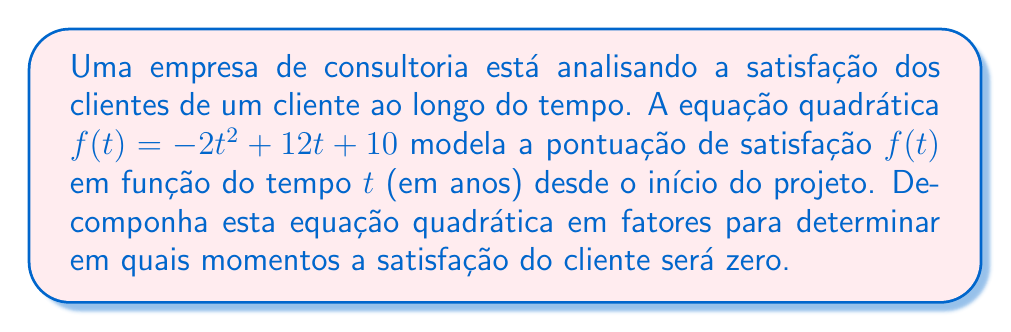Provide a solution to this math problem. Para decompor a equação quadrática $f(t) = -2t^2 + 12t + 10$ em fatores, seguiremos estes passos:

1) Primeiro, identificamos os coeficientes:
   $a = -2$, $b = 12$, $c = 10$

2) Usamos a fórmula quadrática para encontrar as raízes:
   $t = \frac{-b \pm \sqrt{b^2 - 4ac}}{2a}$

3) Substituímos os valores:
   $t = \frac{-12 \pm \sqrt{12^2 - 4(-2)(10)}}{2(-2)}$
   $= \frac{-12 \pm \sqrt{144 + 80}}{-4}$
   $= \frac{-12 \pm \sqrt{224}}{-4}$
   $= \frac{-12 \pm 2\sqrt{56}}{-4}$

4) Simplificamos:
   $t = \frac{12 \mp 2\sqrt{56}}{4}$
   $= 3 \mp \frac{\sqrt{56}}{2}$
   $= 3 \mp \frac{2\sqrt{14}}{2}$
   $= 3 \mp \sqrt{14}$

5) Portanto, as raízes são:
   $t_1 = 3 + \sqrt{14}$ e $t_2 = 3 - \sqrt{14}$

6) A forma fatorada da equação é:
   $f(t) = -2(t - (3 + \sqrt{14}))(t - (3 - \sqrt{14}))$

Isso significa que a satisfação do cliente será zero aproximadamente 6.74 anos e -0.74 anos após o início do projeto. Como o tempo negativo não é relevante neste contexto, apenas o valor positivo é significativo para a análise.
Answer: $f(t) = -2(t - (3 + \sqrt{14}))(t - (3 - \sqrt{14}))$ 